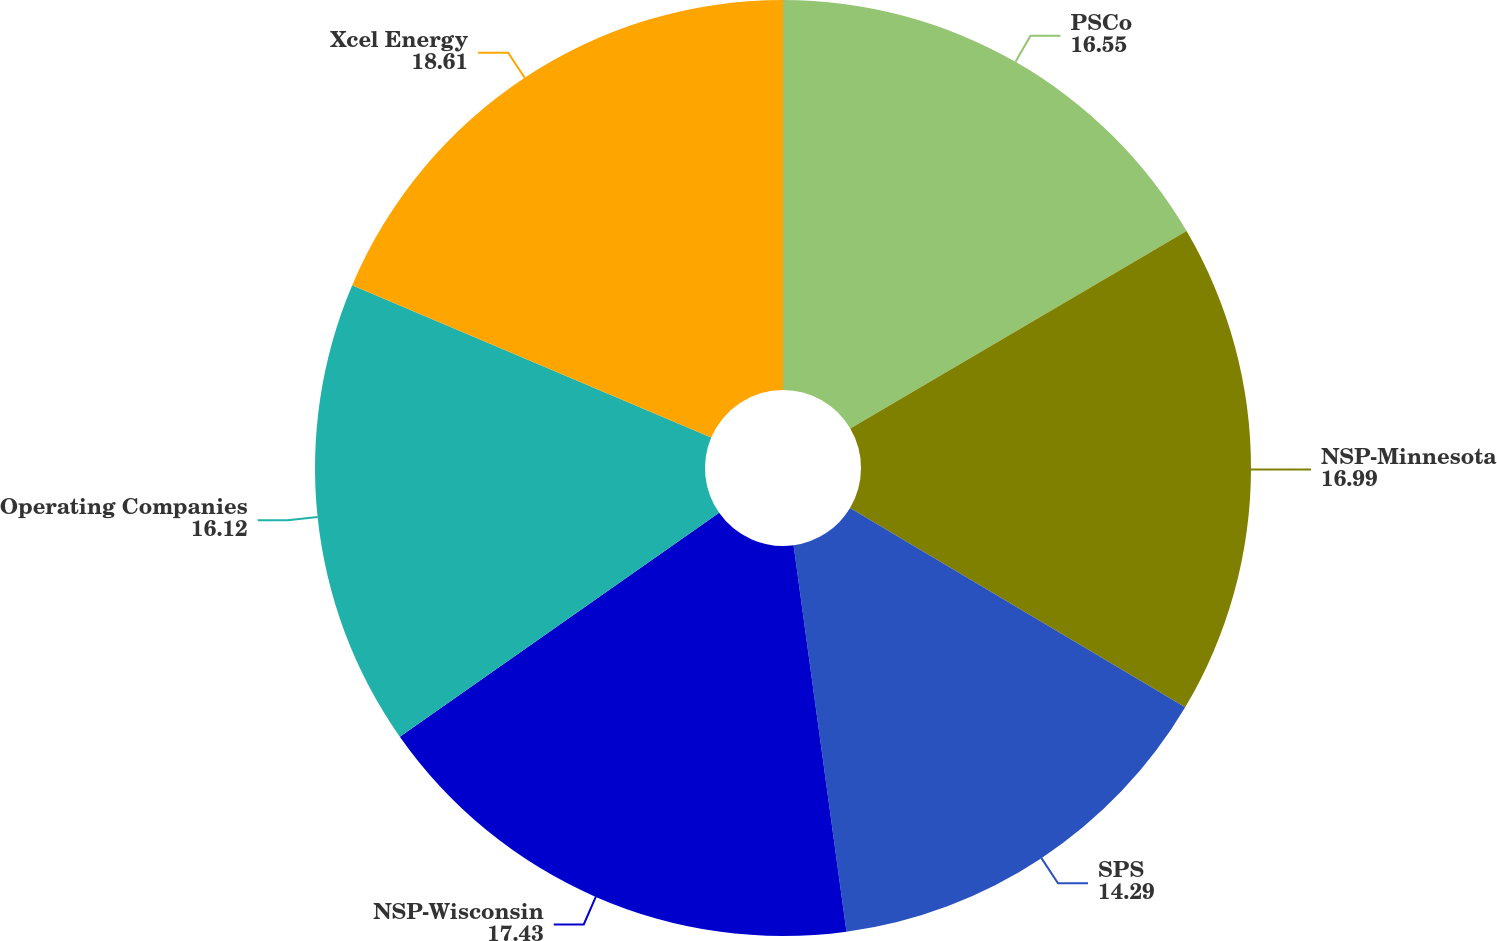Convert chart. <chart><loc_0><loc_0><loc_500><loc_500><pie_chart><fcel>PSCo<fcel>NSP-Minnesota<fcel>SPS<fcel>NSP-Wisconsin<fcel>Operating Companies<fcel>Xcel Energy<nl><fcel>16.55%<fcel>16.99%<fcel>14.29%<fcel>17.43%<fcel>16.12%<fcel>18.61%<nl></chart> 